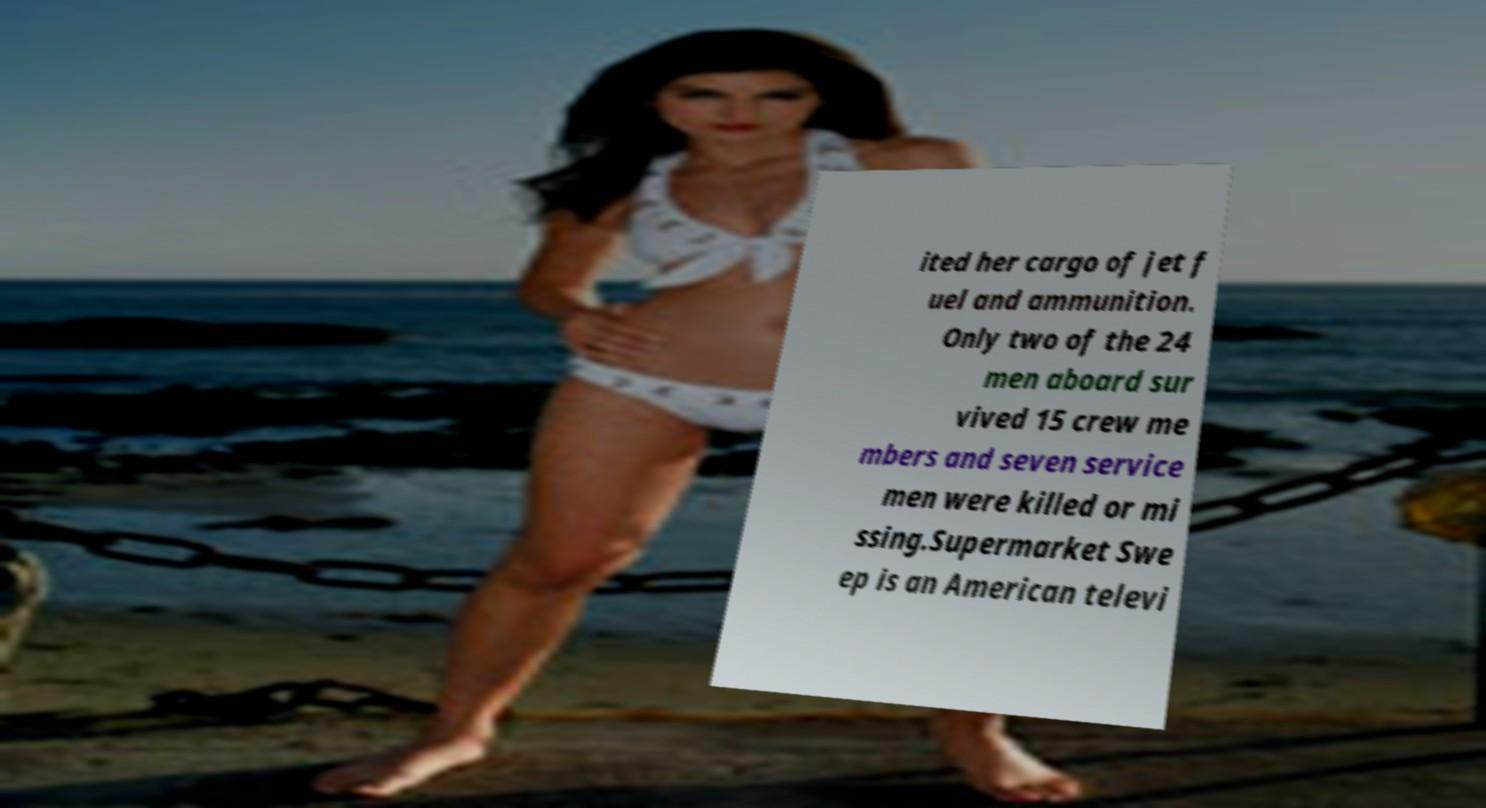Can you accurately transcribe the text from the provided image for me? ited her cargo of jet f uel and ammunition. Only two of the 24 men aboard sur vived 15 crew me mbers and seven service men were killed or mi ssing.Supermarket Swe ep is an American televi 